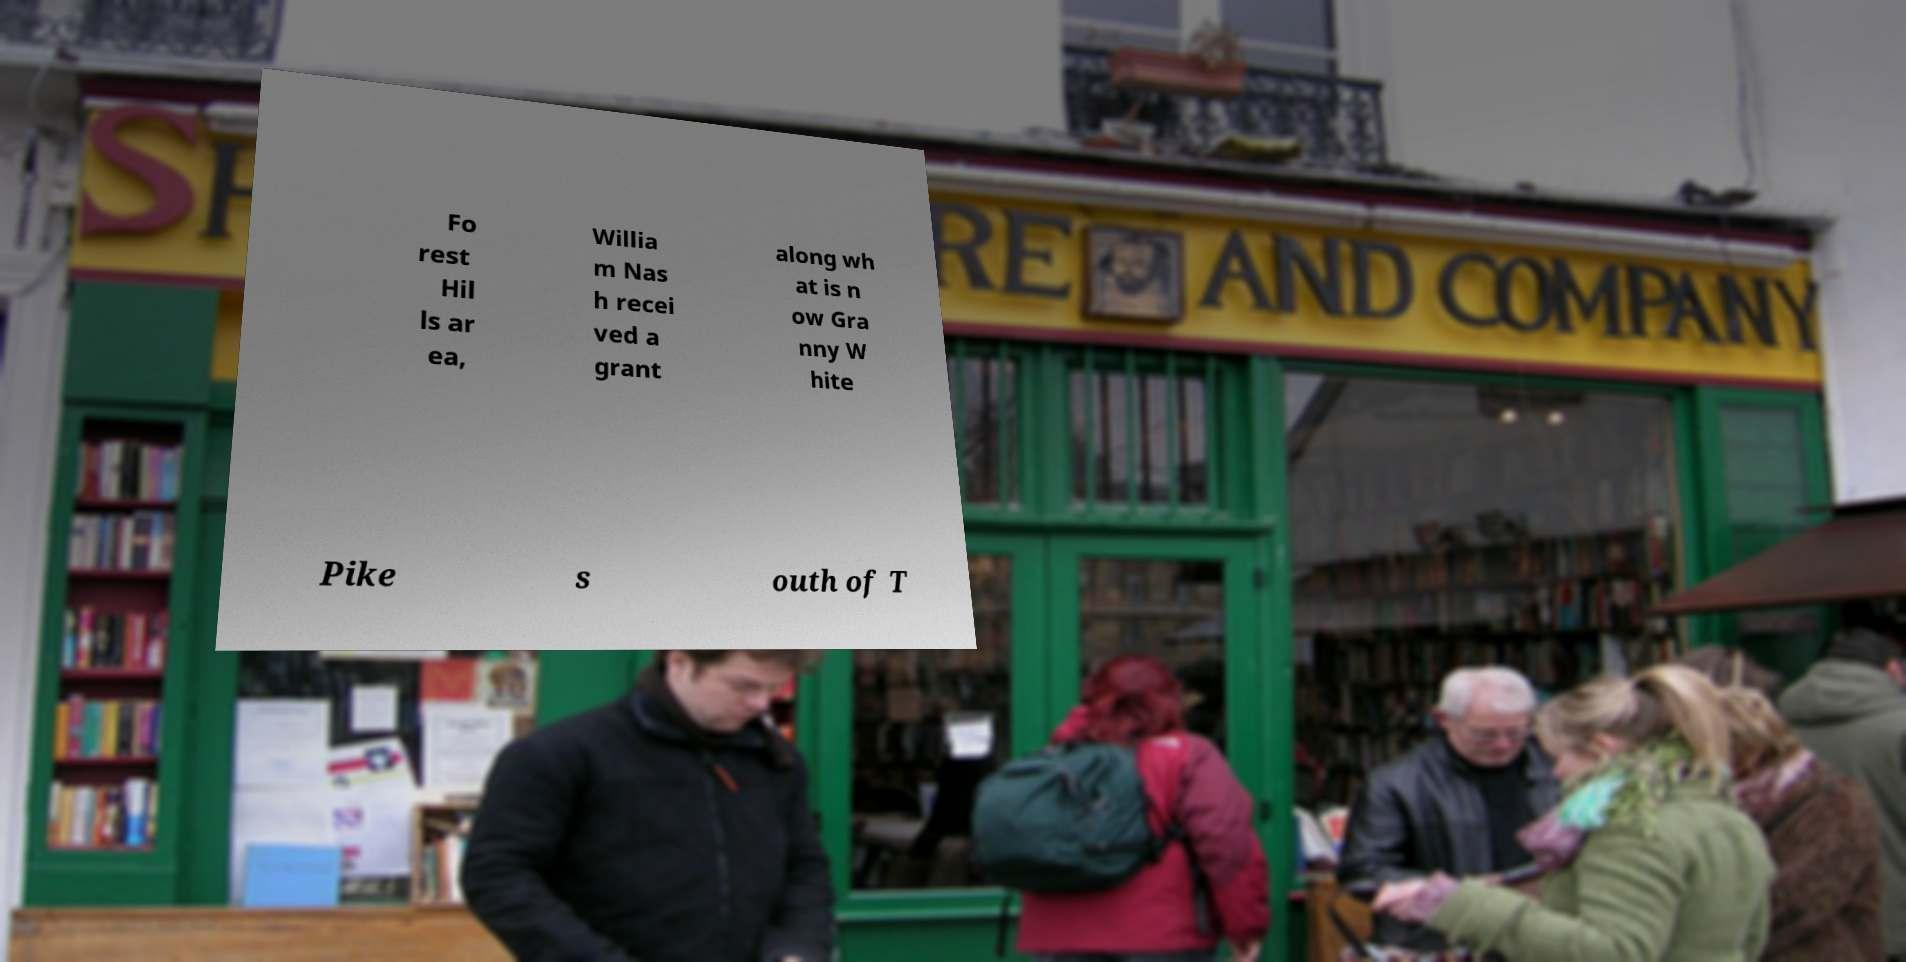Please identify and transcribe the text found in this image. Fo rest Hil ls ar ea, Willia m Nas h recei ved a grant along wh at is n ow Gra nny W hite Pike s outh of T 